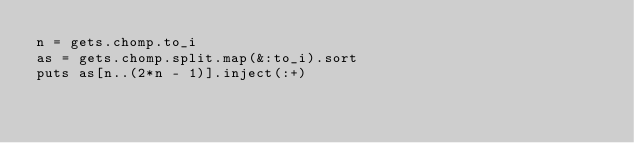Convert code to text. <code><loc_0><loc_0><loc_500><loc_500><_Ruby_>n = gets.chomp.to_i
as = gets.chomp.split.map(&:to_i).sort
puts as[n..(2*n - 1)].inject(:+)
</code> 